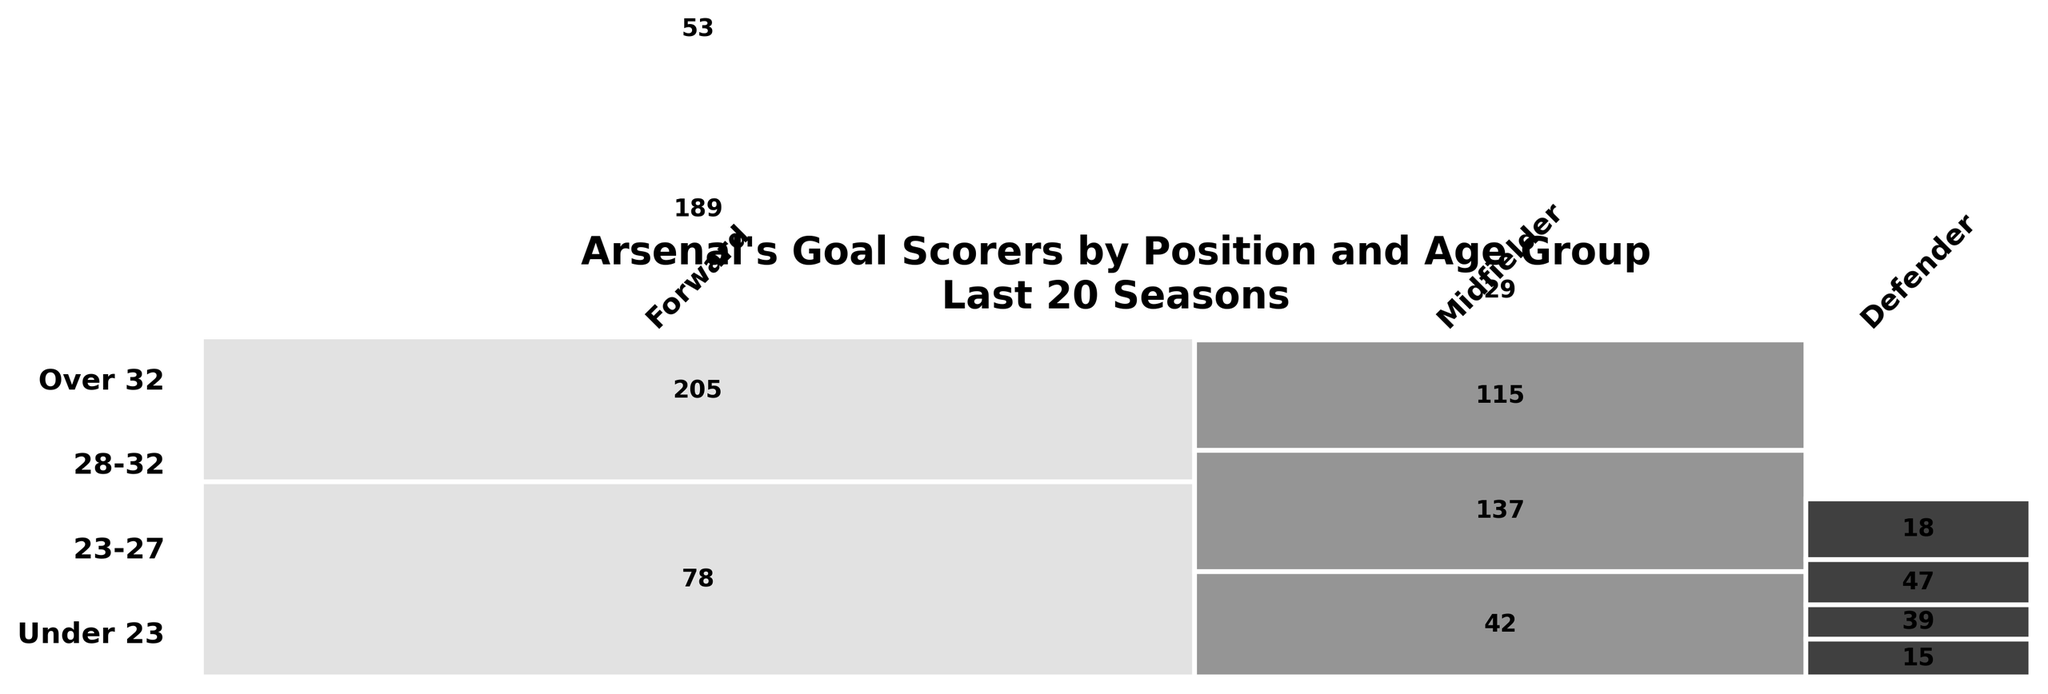What is the title of the plot? The title is typically located above the plot and provides a concise description of what the plot represents. In this case, it is written in bold font at the top.
Answer: Arsenal's Goal Scorers by Position and Age Group\nLast 20 Seasons Which position has the highest number of goal scorers in the '23-27' age group? The width of the segments represents the proportion of goals for each position. The segment labeled 'Forward' is the widest among the '23-27' age group.
Answer: Forward How many goals were scored by midfielders in the '28-32' age group? Locate the segment corresponding to 'Midfielder' in the '28-32' age group. The number inside the segment indicates the goals scored.
Answer: 115 Compare the total number of goals scored by defenders versus midfielders. Which is higher? Sum the goals for all age groups for each position. Defenders: 15 + 39 + 47 + 18 = 119. Midfielders: 42 + 137 + 115 + 29 = 323.
Answer: Midfielders Which age group has the least number of goals scored by forwards? Compare the height of the segments labeled 'Forward' across different age groups. The 'Under 23' age group has the smallest height.
Answer: Under 23 What is the combined total of goals scored by players over 32 across all positions? Sum the goals for the 'Over 32' age group across all positions: 53 (Forward) + 29 (Midfielder) + 18 (Defender).
Answer: 100 In which age group do defenders score the most goals? Compare the height of the 'Defender' segments across different age groups. The '28-32' age group is the tallest.
Answer: 28-32 How do the goals scored by forwards in '23-27' compare to those in '28-32'? Locate the segments for forwards in '23-27' and '28-32'. The goal numbers inside the segments are 205 and 189, respectively.
Answer: Higher in 23-27 Which age group has the highest number of goals across all positions combined? Sum the goals for each age group: Under 23 (135), 23-27 (381), 28-32 (351), Over 32 (100).
Answer: 23-27 